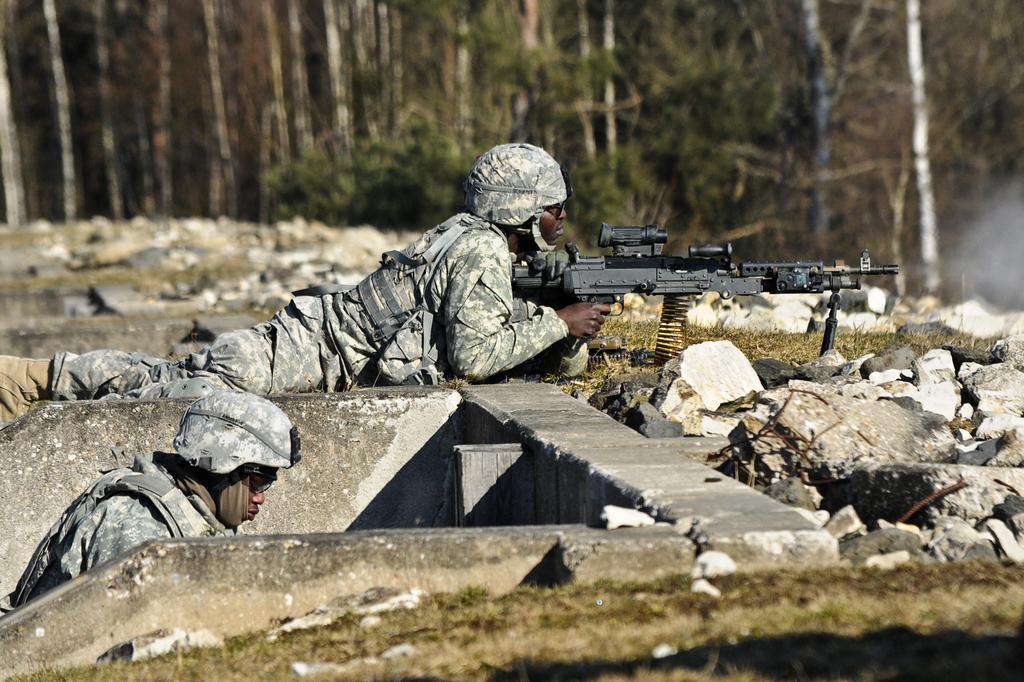How would you summarize this image in a sentence or two? In this picture I can see two persons, there is a person lying and holding a rifle, there are rocks, and in the background there are trees. 